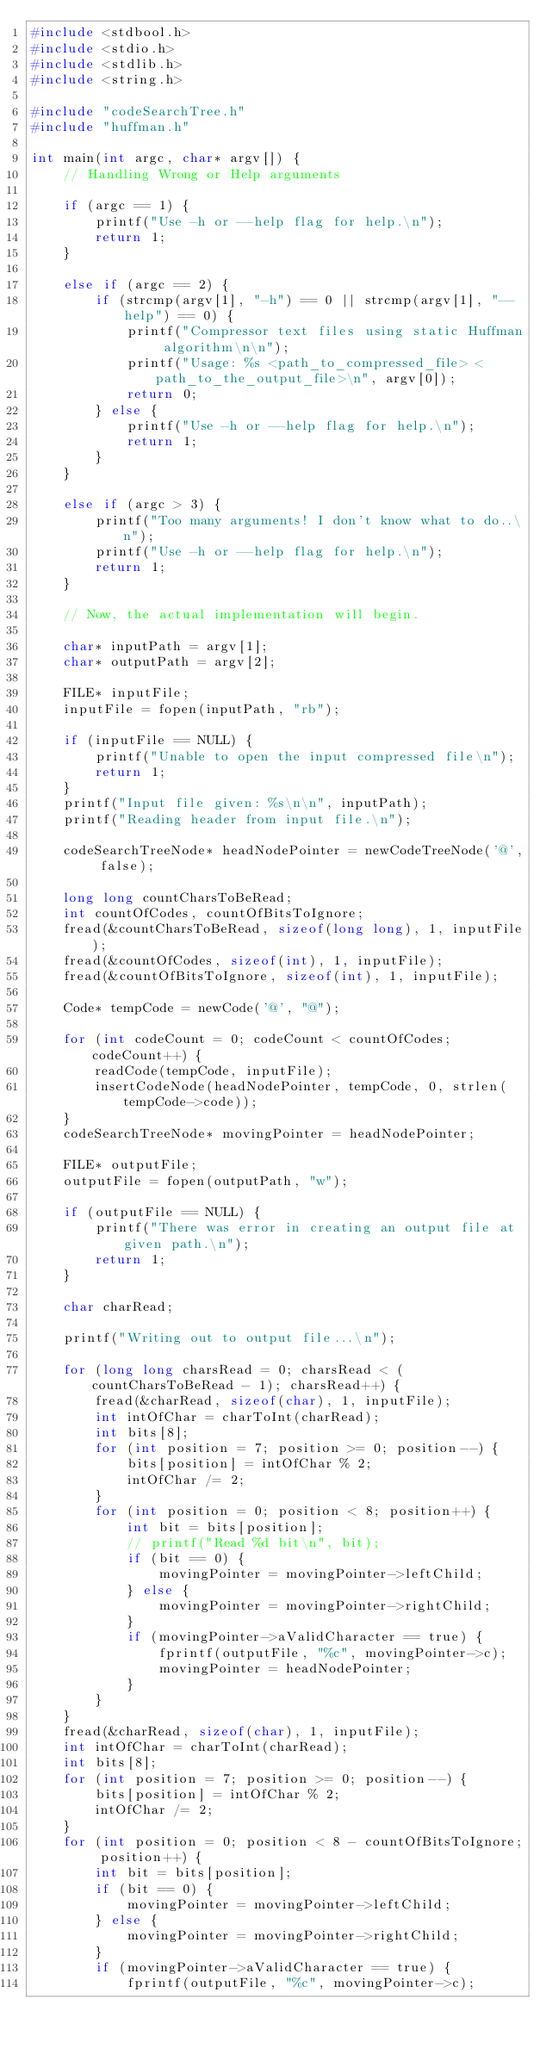<code> <loc_0><loc_0><loc_500><loc_500><_C_>#include <stdbool.h>
#include <stdio.h>
#include <stdlib.h>
#include <string.h>

#include "codeSearchTree.h"
#include "huffman.h"

int main(int argc, char* argv[]) {
    // Handling Wrong or Help arguments

    if (argc == 1) {
        printf("Use -h or --help flag for help.\n");
        return 1;
    }

    else if (argc == 2) {
        if (strcmp(argv[1], "-h") == 0 || strcmp(argv[1], "--help") == 0) {
            printf("Compressor text files using static Huffman algorithm\n\n");
            printf("Usage: %s <path_to_compressed_file> <path_to_the_output_file>\n", argv[0]);
            return 0;
        } else {
            printf("Use -h or --help flag for help.\n");
            return 1;
        }
    }

    else if (argc > 3) {
        printf("Too many arguments! I don't know what to do..\n");
        printf("Use -h or --help flag for help.\n");
        return 1;
    }

    // Now, the actual implementation will begin.

    char* inputPath = argv[1];
    char* outputPath = argv[2];

    FILE* inputFile;
    inputFile = fopen(inputPath, "rb");

    if (inputFile == NULL) {
        printf("Unable to open the input compressed file\n");
        return 1;
    }
    printf("Input file given: %s\n\n", inputPath);
    printf("Reading header from input file.\n");

    codeSearchTreeNode* headNodePointer = newCodeTreeNode('@', false);

    long long countCharsToBeRead;
    int countOfCodes, countOfBitsToIgnore;
    fread(&countCharsToBeRead, sizeof(long long), 1, inputFile);
    fread(&countOfCodes, sizeof(int), 1, inputFile);
    fread(&countOfBitsToIgnore, sizeof(int), 1, inputFile);

    Code* tempCode = newCode('@', "@");

    for (int codeCount = 0; codeCount < countOfCodes; codeCount++) {
        readCode(tempCode, inputFile);
        insertCodeNode(headNodePointer, tempCode, 0, strlen(tempCode->code));
    }
    codeSearchTreeNode* movingPointer = headNodePointer;

    FILE* outputFile;
    outputFile = fopen(outputPath, "w");

    if (outputFile == NULL) {
        printf("There was error in creating an output file at given path.\n");
        return 1;
    }

    char charRead;

    printf("Writing out to output file...\n");

    for (long long charsRead = 0; charsRead < (countCharsToBeRead - 1); charsRead++) {
        fread(&charRead, sizeof(char), 1, inputFile);
        int intOfChar = charToInt(charRead);
        int bits[8];
        for (int position = 7; position >= 0; position--) {
            bits[position] = intOfChar % 2;
            intOfChar /= 2;
        }
        for (int position = 0; position < 8; position++) {
            int bit = bits[position];
            // printf("Read %d bit\n", bit);
            if (bit == 0) {
                movingPointer = movingPointer->leftChild;
            } else {
                movingPointer = movingPointer->rightChild;
            }
            if (movingPointer->aValidCharacter == true) {
                fprintf(outputFile, "%c", movingPointer->c);
                movingPointer = headNodePointer;
            }
        }
    }
    fread(&charRead, sizeof(char), 1, inputFile);
    int intOfChar = charToInt(charRead);
    int bits[8];
    for (int position = 7; position >= 0; position--) {
        bits[position] = intOfChar % 2;
        intOfChar /= 2;
    }
    for (int position = 0; position < 8 - countOfBitsToIgnore; position++) {
        int bit = bits[position];
        if (bit == 0) {
            movingPointer = movingPointer->leftChild;
        } else {
            movingPointer = movingPointer->rightChild;
        }
        if (movingPointer->aValidCharacter == true) {
            fprintf(outputFile, "%c", movingPointer->c);</code> 